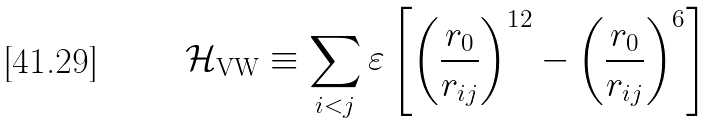Convert formula to latex. <formula><loc_0><loc_0><loc_500><loc_500>\mathcal { H } _ { \text {VW} } \equiv \sum _ { i < j } \varepsilon \left [ \left ( \frac { r _ { 0 } } { r _ { i j } } \right ) ^ { 1 2 } - \left ( \frac { r _ { 0 } } { r _ { i j } } \right ) ^ { 6 } \right ]</formula> 